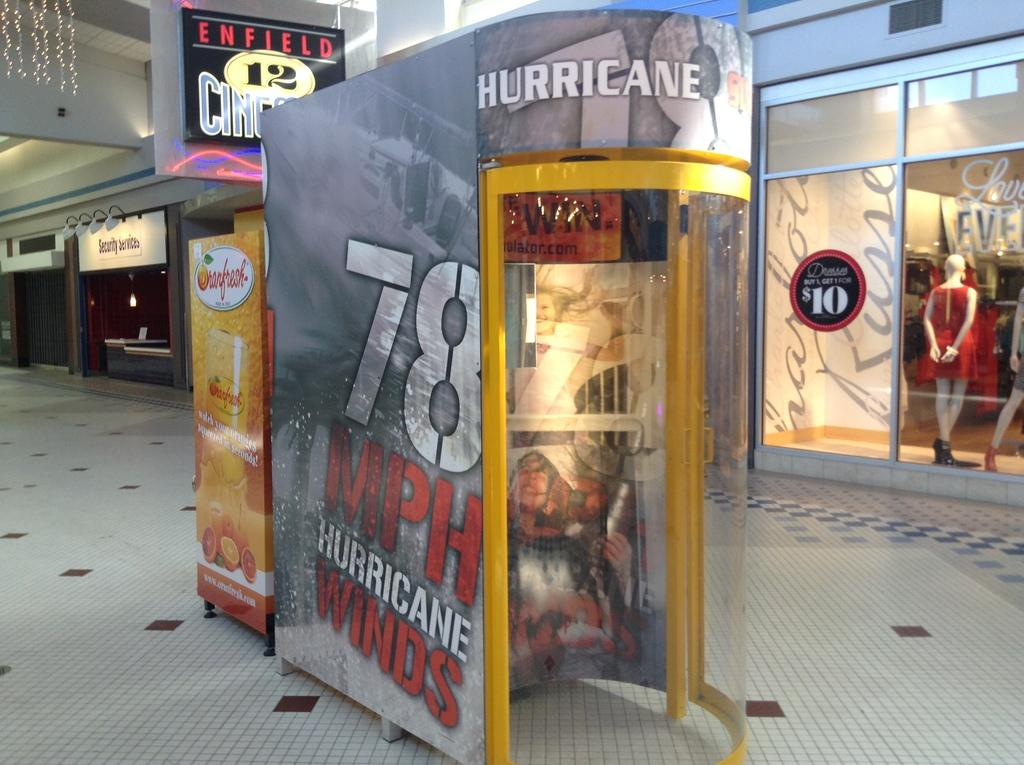What is the main structure in the center of the image? There is a booth at the center of the image. What is located beside the booth? There is a banner with images and text beside the booth. What can be seen in the background of the image? There are stalls and a board with some text in the background of the image. How many trees are visible in the image? There are no trees visible in the image. What type of line is present in the image? There is no line present in the image. 